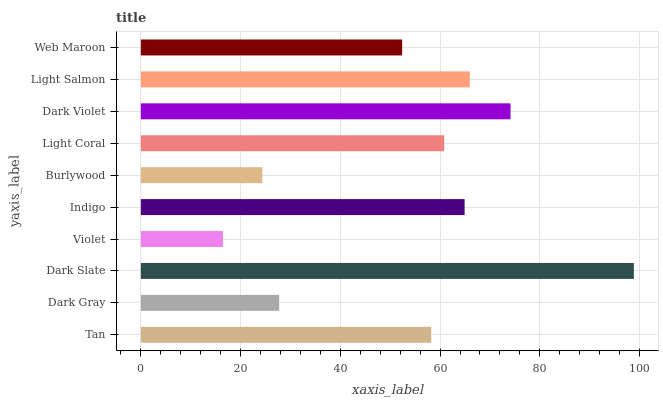Is Violet the minimum?
Answer yes or no. Yes. Is Dark Slate the maximum?
Answer yes or no. Yes. Is Dark Gray the minimum?
Answer yes or no. No. Is Dark Gray the maximum?
Answer yes or no. No. Is Tan greater than Dark Gray?
Answer yes or no. Yes. Is Dark Gray less than Tan?
Answer yes or no. Yes. Is Dark Gray greater than Tan?
Answer yes or no. No. Is Tan less than Dark Gray?
Answer yes or no. No. Is Light Coral the high median?
Answer yes or no. Yes. Is Tan the low median?
Answer yes or no. Yes. Is Burlywood the high median?
Answer yes or no. No. Is Violet the low median?
Answer yes or no. No. 